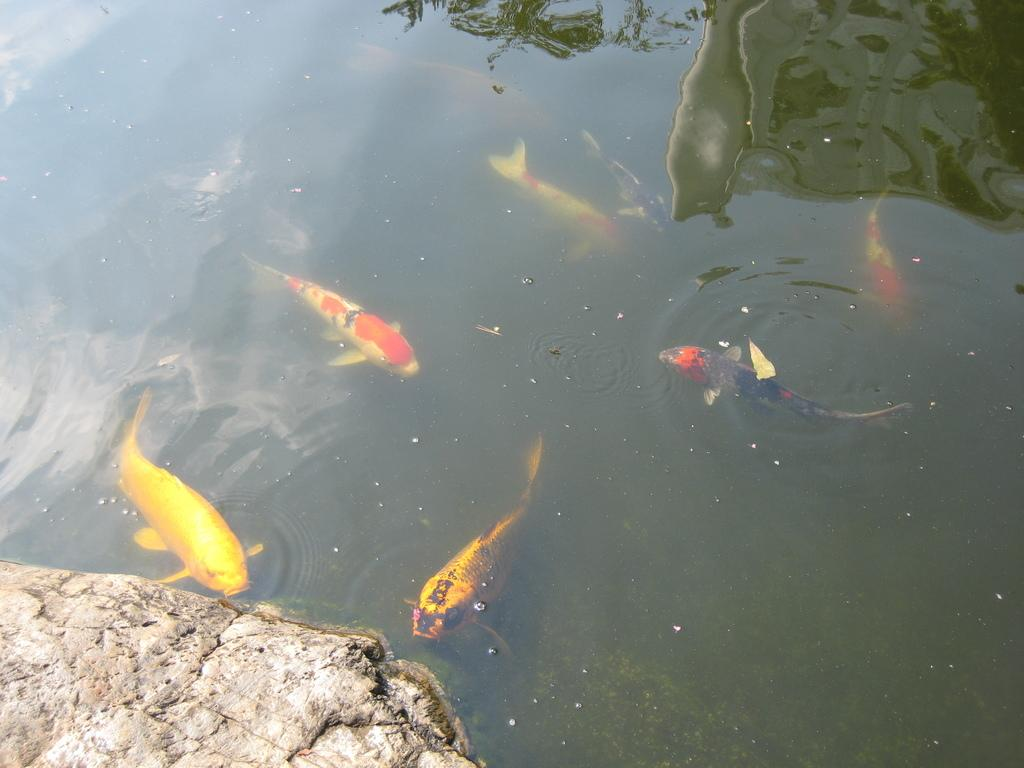What types of animals can be seen in the image? There are different colors of fishes in the image. What other objects or features can be seen in the image? There is a rock in the image. What can be observed in the water in the image? There are bubbles in the water in the image. What type of support can be seen in the image? There is no support present in the image; it features fishes, a rock, and bubbles in the water. What knowledge can be gained from observing the fishes in the image? The image does not provide any specific knowledge about the fishes; it simply shows their colors and presence in the water. 